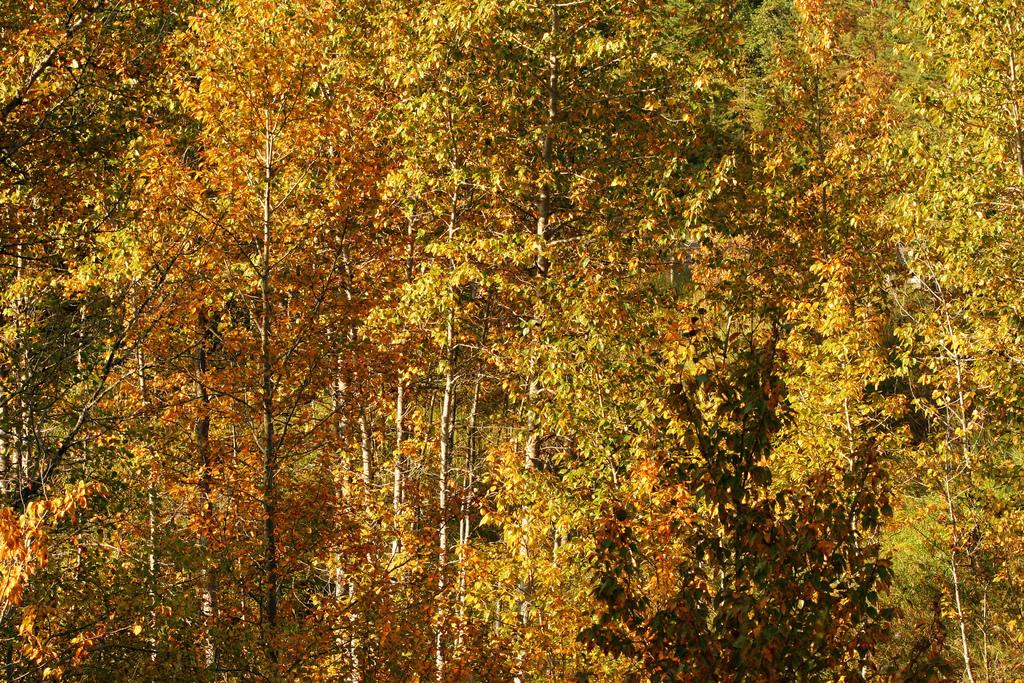What type of vegetation can be seen in the image? There are a few trees in the image. Can you describe the trees in the image? The trees in the image are not described in detail, but they are present. What is the primary purpose of the trees in the image? The primary purpose of the trees in the image is not specified, but they are likely part of the natural landscape. What shape is the horn of the unicorn in the image? There is no unicorn or horn present in the image; it only features a few trees. 